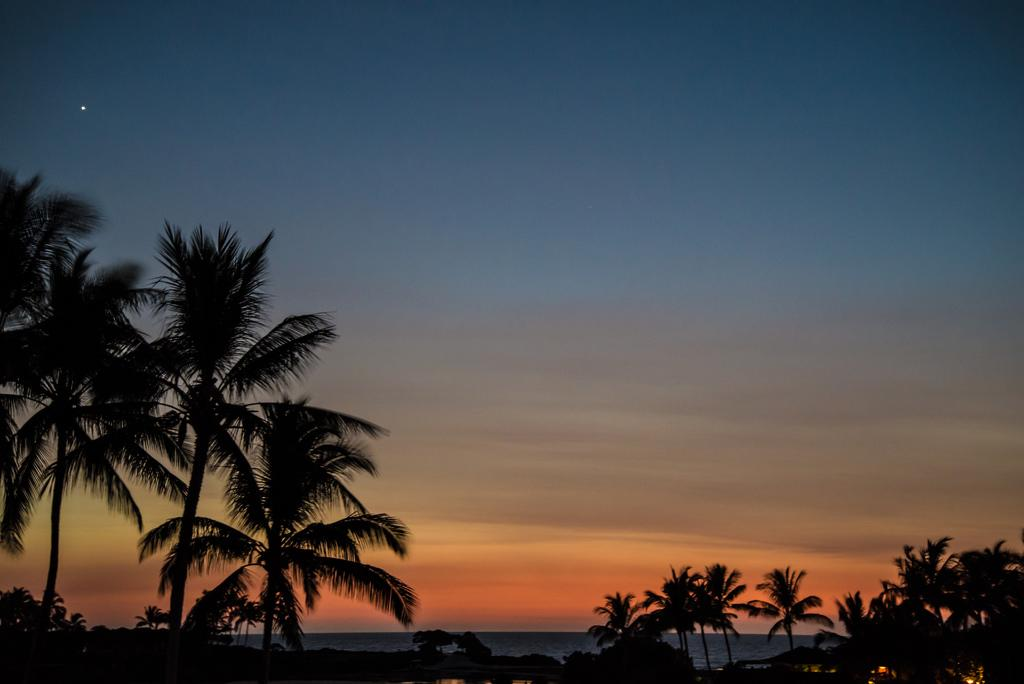What type of vegetation can be seen in the image? There are trees in the image. What type of structure is visible in the image? There appears to be a house with lighting in the image. Can you describe the possible setting of the image? The image may depict the sea. What type of dog can be seen playing in the air in the image? There is no dog present in the image, and it does not depict any animals playing in the air. 